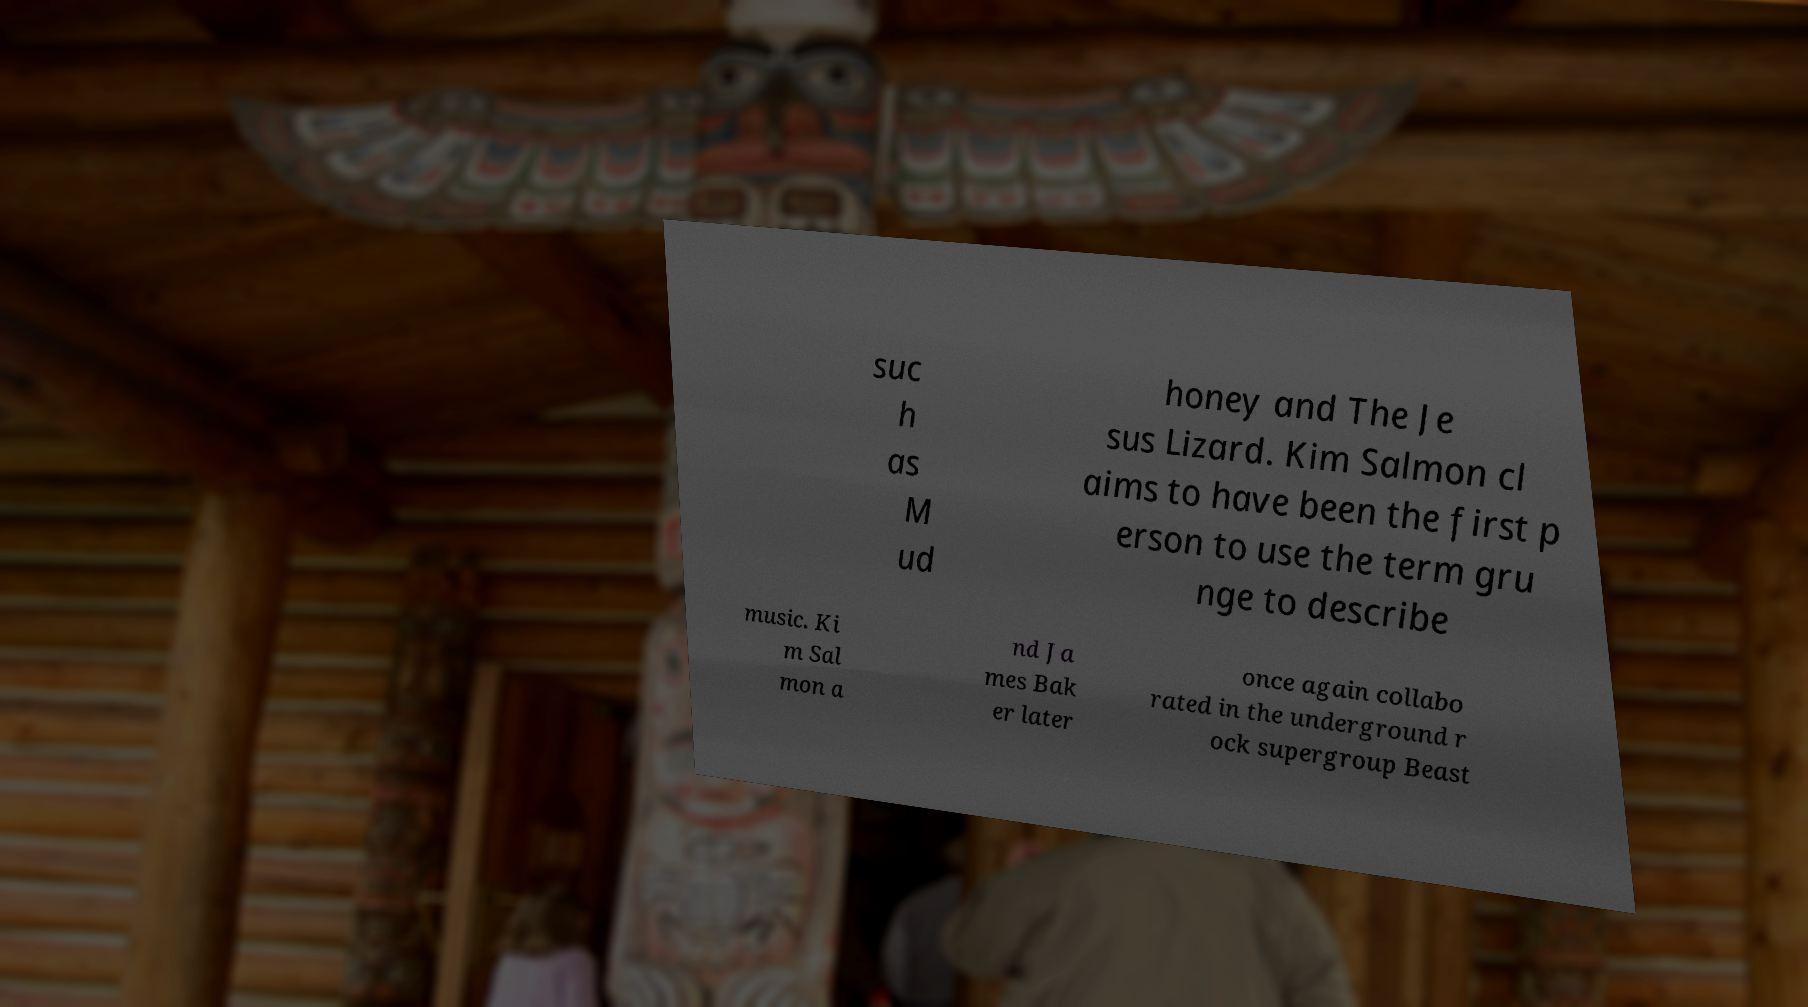Could you assist in decoding the text presented in this image and type it out clearly? suc h as M ud honey and The Je sus Lizard. Kim Salmon cl aims to have been the first p erson to use the term gru nge to describe music. Ki m Sal mon a nd Ja mes Bak er later once again collabo rated in the underground r ock supergroup Beast 